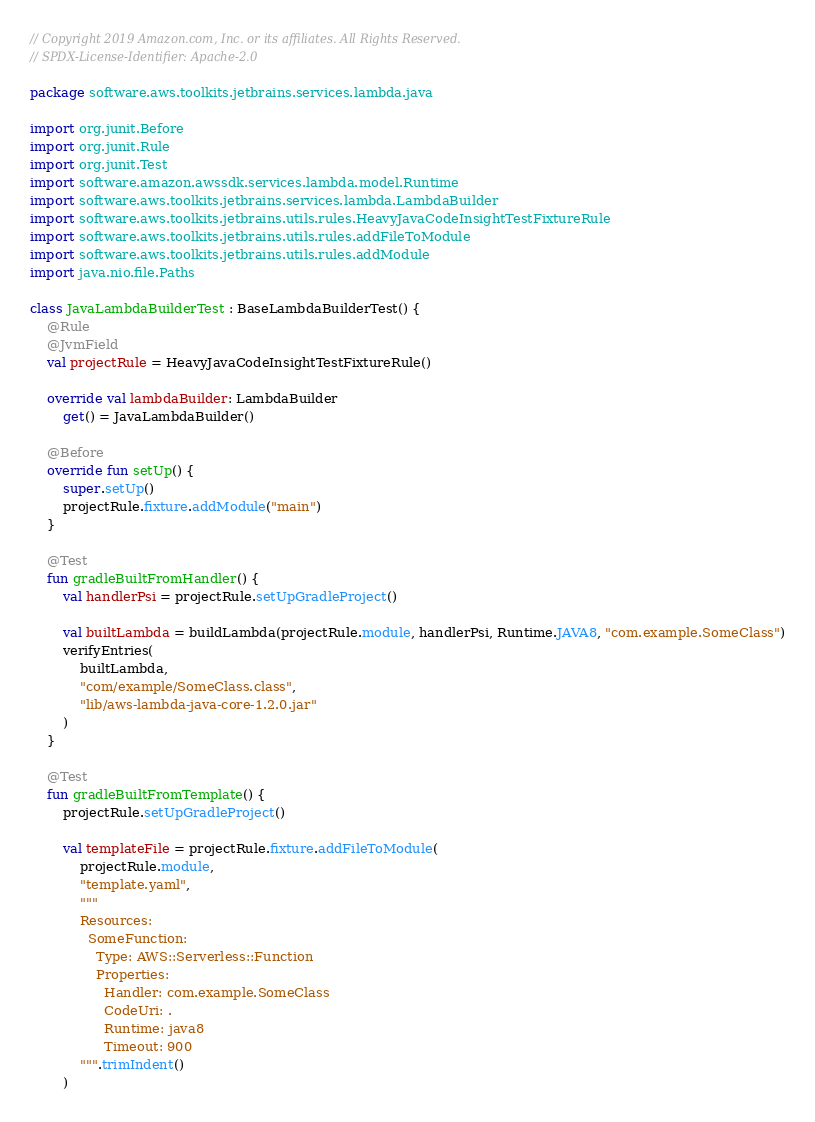<code> <loc_0><loc_0><loc_500><loc_500><_Kotlin_>// Copyright 2019 Amazon.com, Inc. or its affiliates. All Rights Reserved.
// SPDX-License-Identifier: Apache-2.0

package software.aws.toolkits.jetbrains.services.lambda.java

import org.junit.Before
import org.junit.Rule
import org.junit.Test
import software.amazon.awssdk.services.lambda.model.Runtime
import software.aws.toolkits.jetbrains.services.lambda.LambdaBuilder
import software.aws.toolkits.jetbrains.utils.rules.HeavyJavaCodeInsightTestFixtureRule
import software.aws.toolkits.jetbrains.utils.rules.addFileToModule
import software.aws.toolkits.jetbrains.utils.rules.addModule
import java.nio.file.Paths

class JavaLambdaBuilderTest : BaseLambdaBuilderTest() {
    @Rule
    @JvmField
    val projectRule = HeavyJavaCodeInsightTestFixtureRule()

    override val lambdaBuilder: LambdaBuilder
        get() = JavaLambdaBuilder()

    @Before
    override fun setUp() {
        super.setUp()
        projectRule.fixture.addModule("main")
    }

    @Test
    fun gradleBuiltFromHandler() {
        val handlerPsi = projectRule.setUpGradleProject()

        val builtLambda = buildLambda(projectRule.module, handlerPsi, Runtime.JAVA8, "com.example.SomeClass")
        verifyEntries(
            builtLambda,
            "com/example/SomeClass.class",
            "lib/aws-lambda-java-core-1.2.0.jar"
        )
    }

    @Test
    fun gradleBuiltFromTemplate() {
        projectRule.setUpGradleProject()

        val templateFile = projectRule.fixture.addFileToModule(
            projectRule.module,
            "template.yaml",
            """
            Resources:
              SomeFunction:
                Type: AWS::Serverless::Function
                Properties:
                  Handler: com.example.SomeClass
                  CodeUri: .
                  Runtime: java8
                  Timeout: 900
            """.trimIndent()
        )</code> 